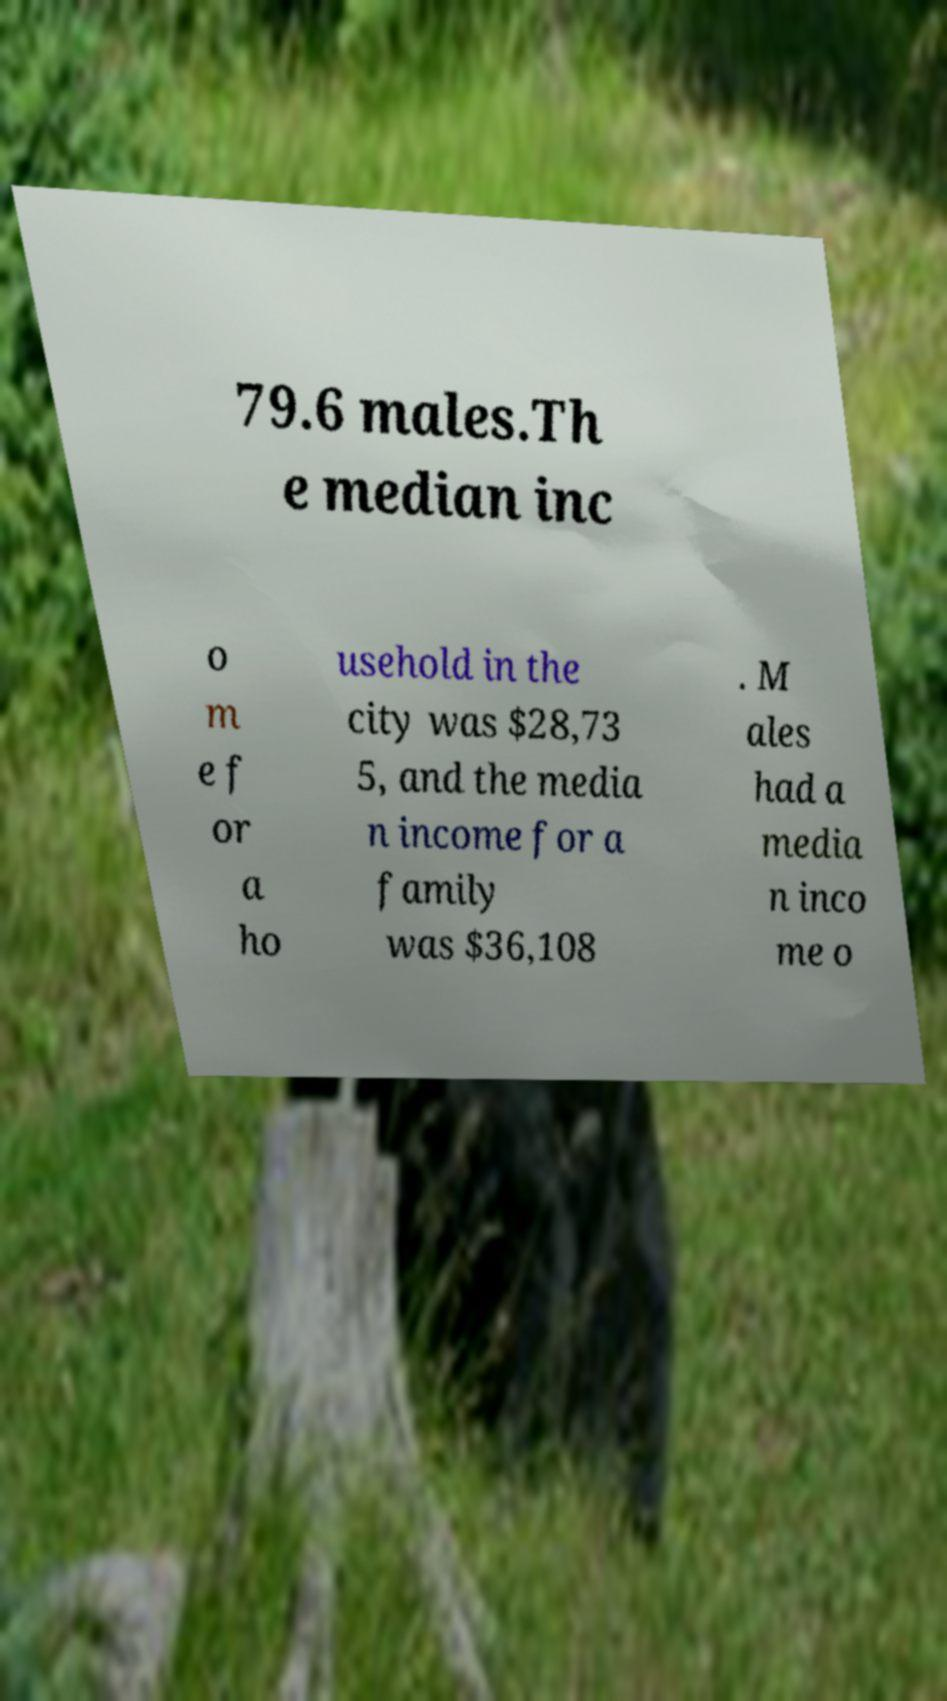Can you accurately transcribe the text from the provided image for me? 79.6 males.Th e median inc o m e f or a ho usehold in the city was $28,73 5, and the media n income for a family was $36,108 . M ales had a media n inco me o 